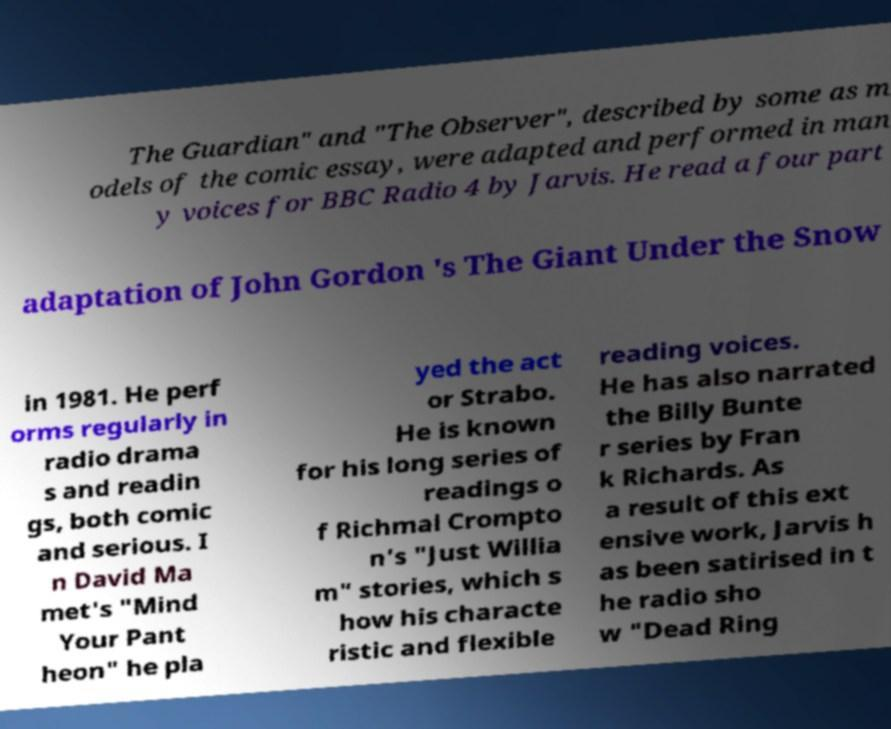Please identify and transcribe the text found in this image. The Guardian" and "The Observer", described by some as m odels of the comic essay, were adapted and performed in man y voices for BBC Radio 4 by Jarvis. He read a four part adaptation of John Gordon 's The Giant Under the Snow in 1981. He perf orms regularly in radio drama s and readin gs, both comic and serious. I n David Ma met's "Mind Your Pant heon" he pla yed the act or Strabo. He is known for his long series of readings o f Richmal Crompto n's "Just Willia m" stories, which s how his characte ristic and flexible reading voices. He has also narrated the Billy Bunte r series by Fran k Richards. As a result of this ext ensive work, Jarvis h as been satirised in t he radio sho w "Dead Ring 